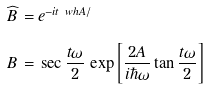<formula> <loc_0><loc_0><loc_500><loc_500>\widehat { B } \, = & \, e ^ { - i t \ w h { A } / } \\ B \, = & \, \sec \frac { t \omega } { 2 } \, \exp \left [ \frac { 2 A } { i \hbar { \omega } } \tan \frac { t \omega } { 2 } \right ]</formula> 